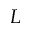<formula> <loc_0><loc_0><loc_500><loc_500>L</formula> 